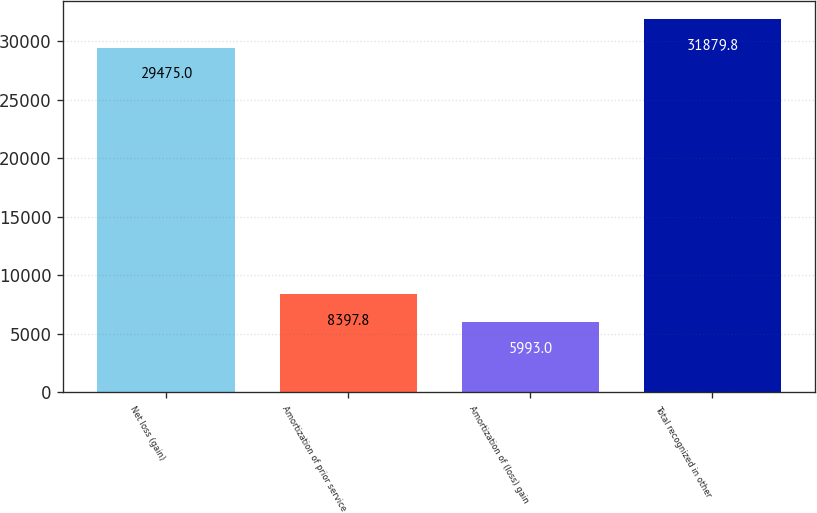Convert chart. <chart><loc_0><loc_0><loc_500><loc_500><bar_chart><fcel>Net loss (gain)<fcel>Amortization of prior service<fcel>Amortization of (loss) gain<fcel>Total recognized in other<nl><fcel>29475<fcel>8397.8<fcel>5993<fcel>31879.8<nl></chart> 